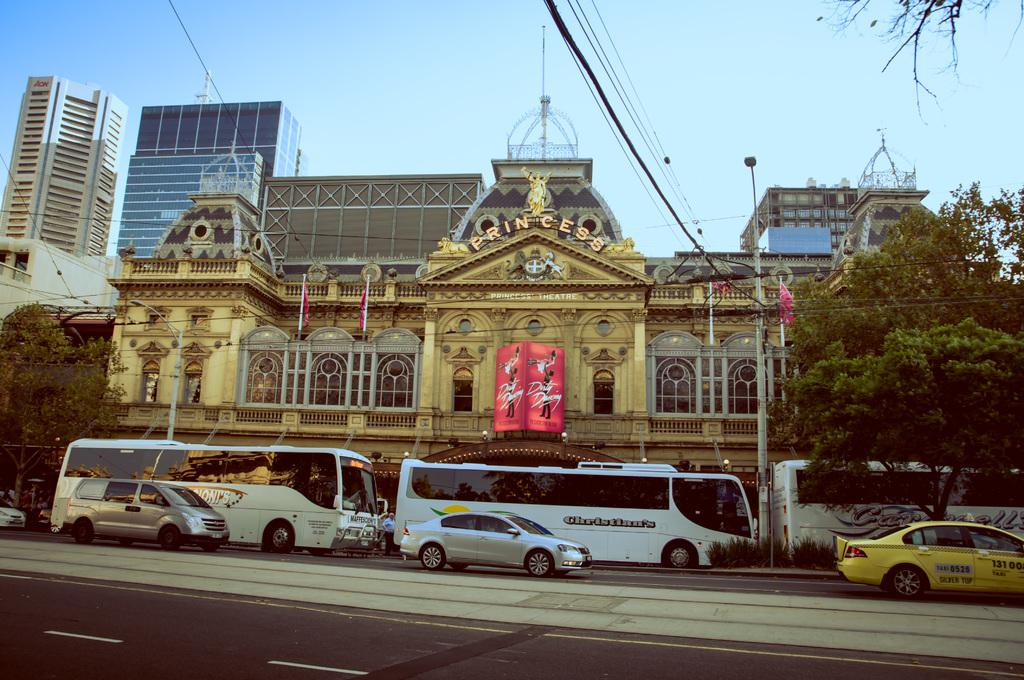<image>
Summarize the visual content of the image. a building that has the word princess at the top 